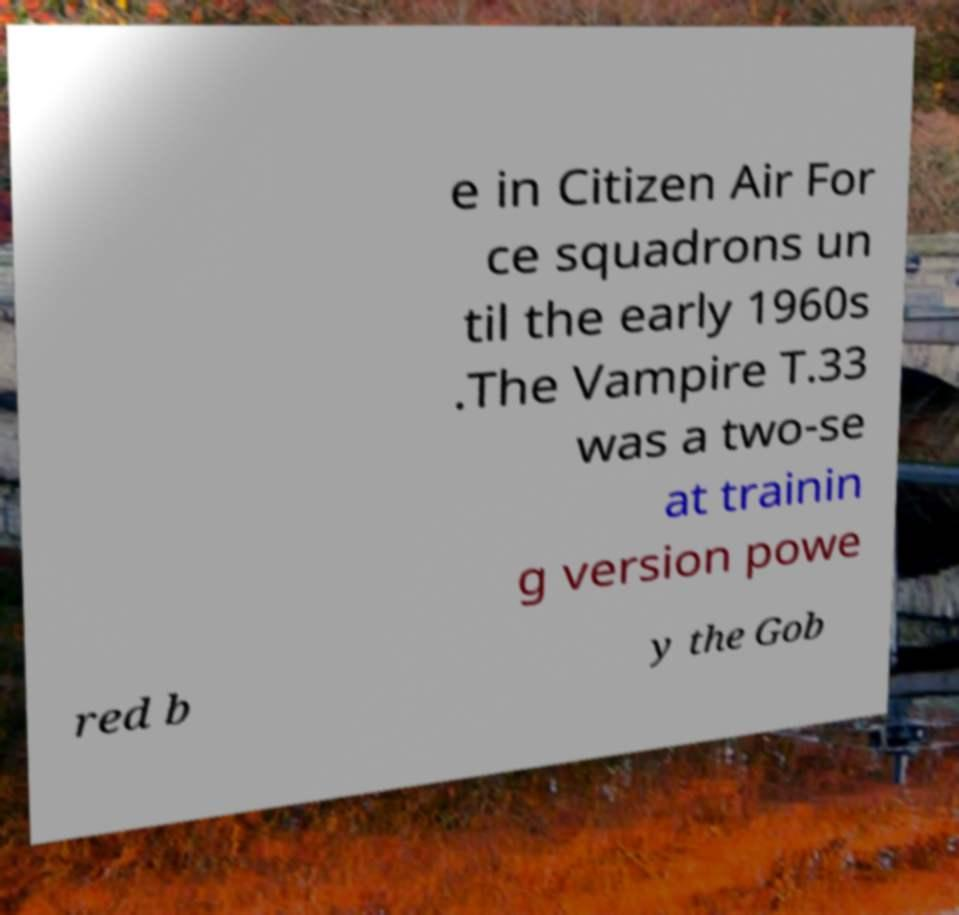There's text embedded in this image that I need extracted. Can you transcribe it verbatim? e in Citizen Air For ce squadrons un til the early 1960s .The Vampire T.33 was a two-se at trainin g version powe red b y the Gob 